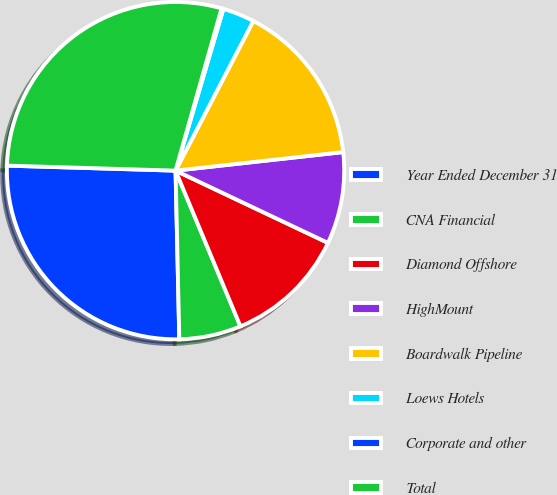<chart> <loc_0><loc_0><loc_500><loc_500><pie_chart><fcel>Year Ended December 31<fcel>CNA Financial<fcel>Diamond Offshore<fcel>HighMount<fcel>Boardwalk Pipeline<fcel>Loews Hotels<fcel>Corporate and other<fcel>Total<nl><fcel>25.83%<fcel>5.93%<fcel>11.67%<fcel>8.8%<fcel>15.62%<fcel>3.05%<fcel>0.18%<fcel>28.92%<nl></chart> 